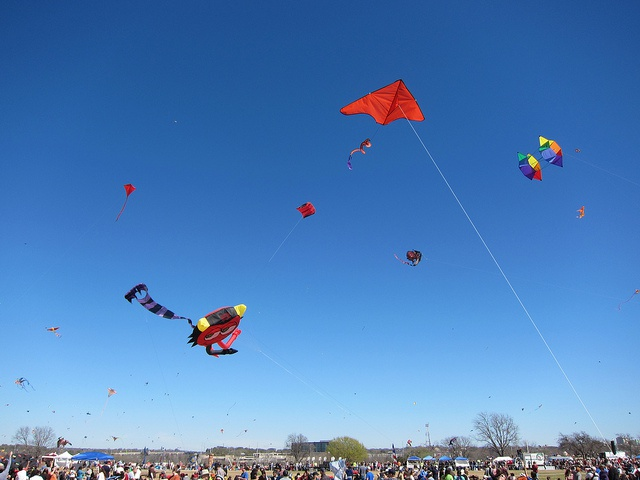Describe the objects in this image and their specific colors. I can see people in darkblue, blue, lightblue, and gray tones, kite in darkblue, black, brown, gray, and maroon tones, kite in darkblue, red, brown, and maroon tones, kite in darkblue, lightblue, and gray tones, and kite in darkblue, blue, orange, and yellow tones in this image. 